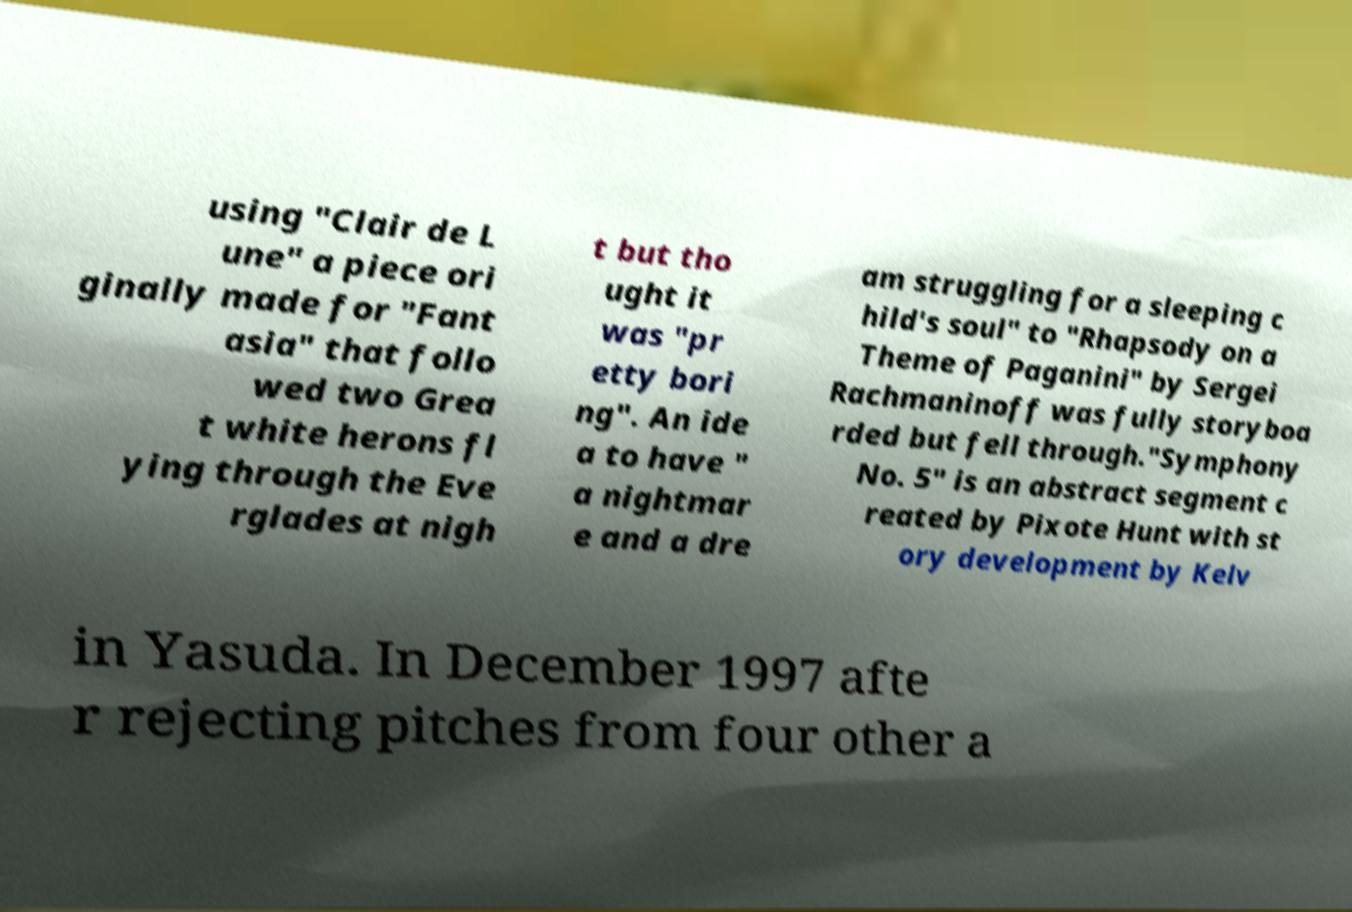For documentation purposes, I need the text within this image transcribed. Could you provide that? using "Clair de L une" a piece ori ginally made for "Fant asia" that follo wed two Grea t white herons fl ying through the Eve rglades at nigh t but tho ught it was "pr etty bori ng". An ide a to have " a nightmar e and a dre am struggling for a sleeping c hild's soul" to "Rhapsody on a Theme of Paganini" by Sergei Rachmaninoff was fully storyboa rded but fell through."Symphony No. 5" is an abstract segment c reated by Pixote Hunt with st ory development by Kelv in Yasuda. In December 1997 afte r rejecting pitches from four other a 